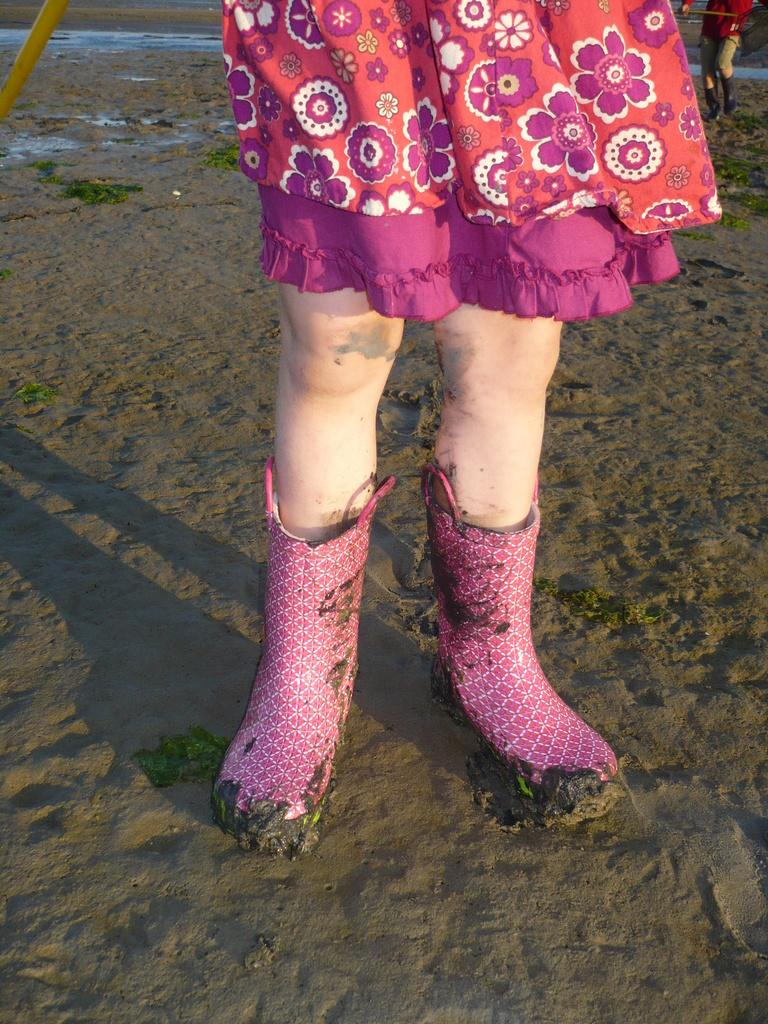What is the main subject of the image? There is a lady person in the image. What is the lady person wearing on her feet? The lady person is wearing pink color boots. What type of clothing is the lady person wearing? The lady person is wearing a multi-color dress. What can be seen in the background of the image? There is sand visible in the background of the image. Are there any other people in the image? Yes, there is at least one person walking in the background of the image. What type of servant can be seen attending to the lady person in the image? There is no servant present in the image; it only features the lady person and other people in the background. How does the lady person react to the rainstorm in the image? There is no rainstorm present in the image; it is set on a sandy background with no indication of precipitation. 